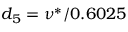Convert formula to latex. <formula><loc_0><loc_0><loc_500><loc_500>d _ { 5 } = \nu ^ { * } / 0 . 6 0 2 5</formula> 